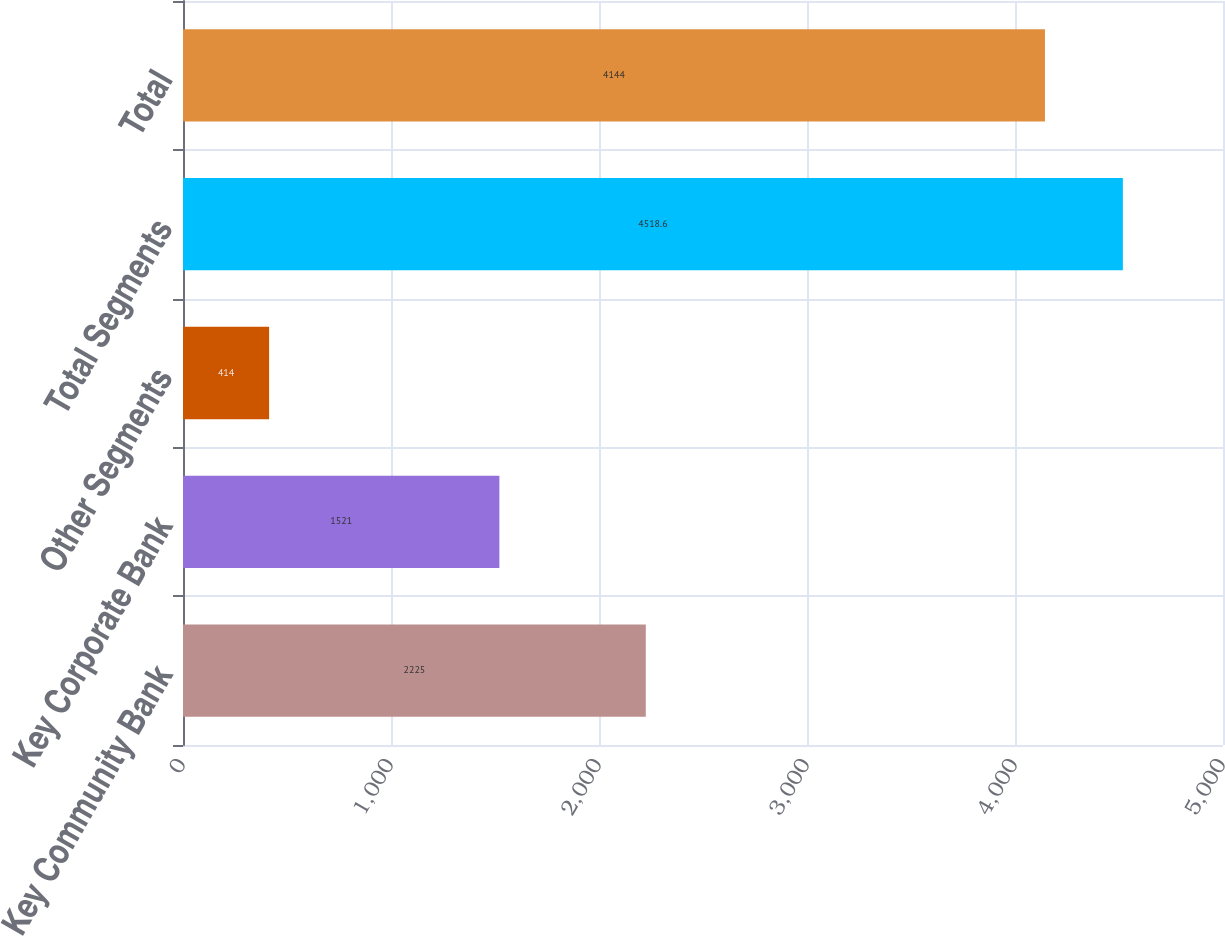<chart> <loc_0><loc_0><loc_500><loc_500><bar_chart><fcel>Key Community Bank<fcel>Key Corporate Bank<fcel>Other Segments<fcel>Total Segments<fcel>Total<nl><fcel>2225<fcel>1521<fcel>414<fcel>4518.6<fcel>4144<nl></chart> 